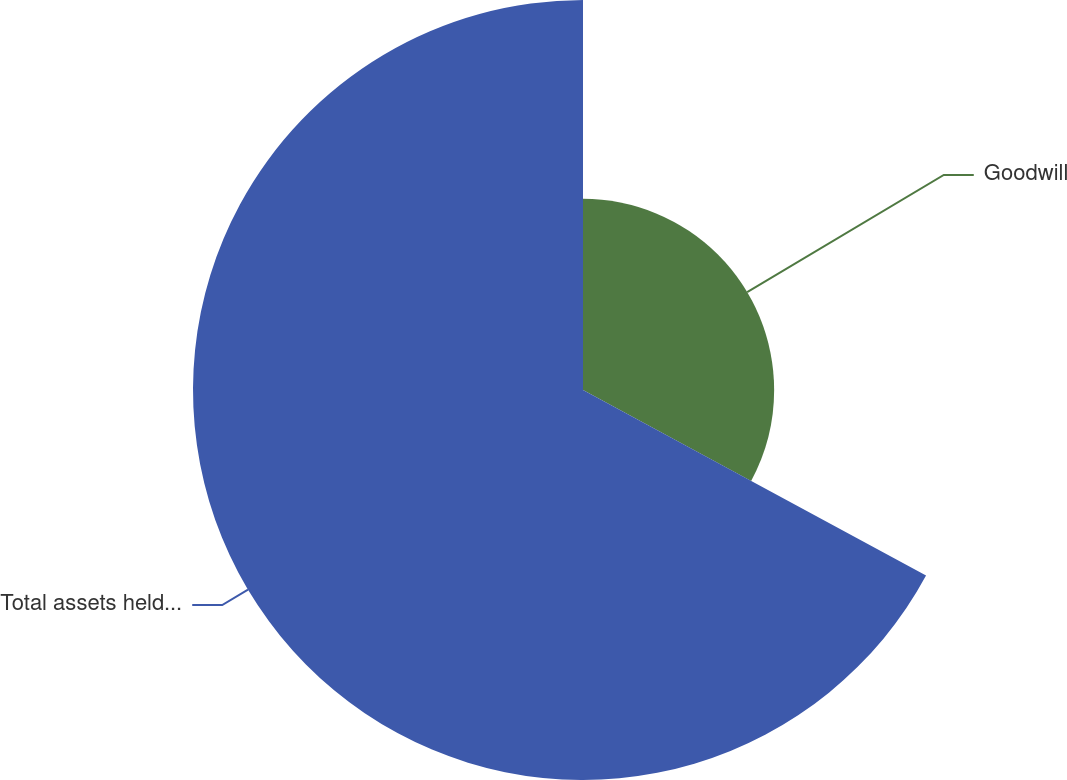Convert chart. <chart><loc_0><loc_0><loc_500><loc_500><pie_chart><fcel>Goodwill<fcel>Total assets held for sale<nl><fcel>32.89%<fcel>67.11%<nl></chart> 